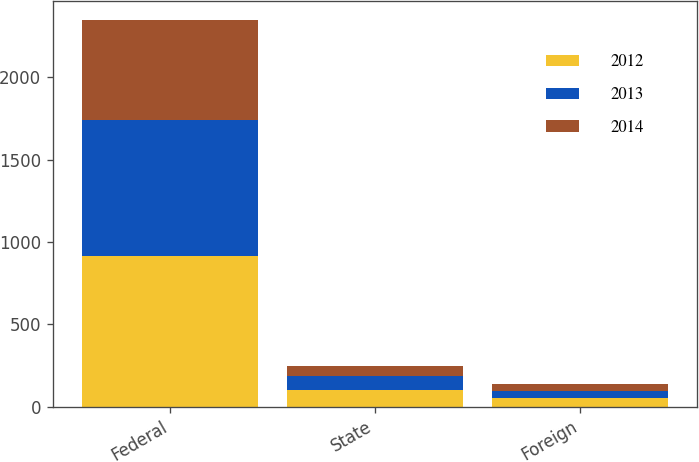<chart> <loc_0><loc_0><loc_500><loc_500><stacked_bar_chart><ecel><fcel>Federal<fcel>State<fcel>Foreign<nl><fcel>2012<fcel>916<fcel>102<fcel>52<nl><fcel>2013<fcel>827<fcel>86<fcel>44<nl><fcel>2014<fcel>604<fcel>58<fcel>43<nl></chart> 